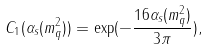<formula> <loc_0><loc_0><loc_500><loc_500>C _ { 1 } ( \alpha _ { s } ( m _ { q } ^ { 2 } ) ) = \exp ( - \frac { 1 6 \alpha _ { s } ( m _ { q } ^ { 2 } ) } { 3 \pi } ) ,</formula> 